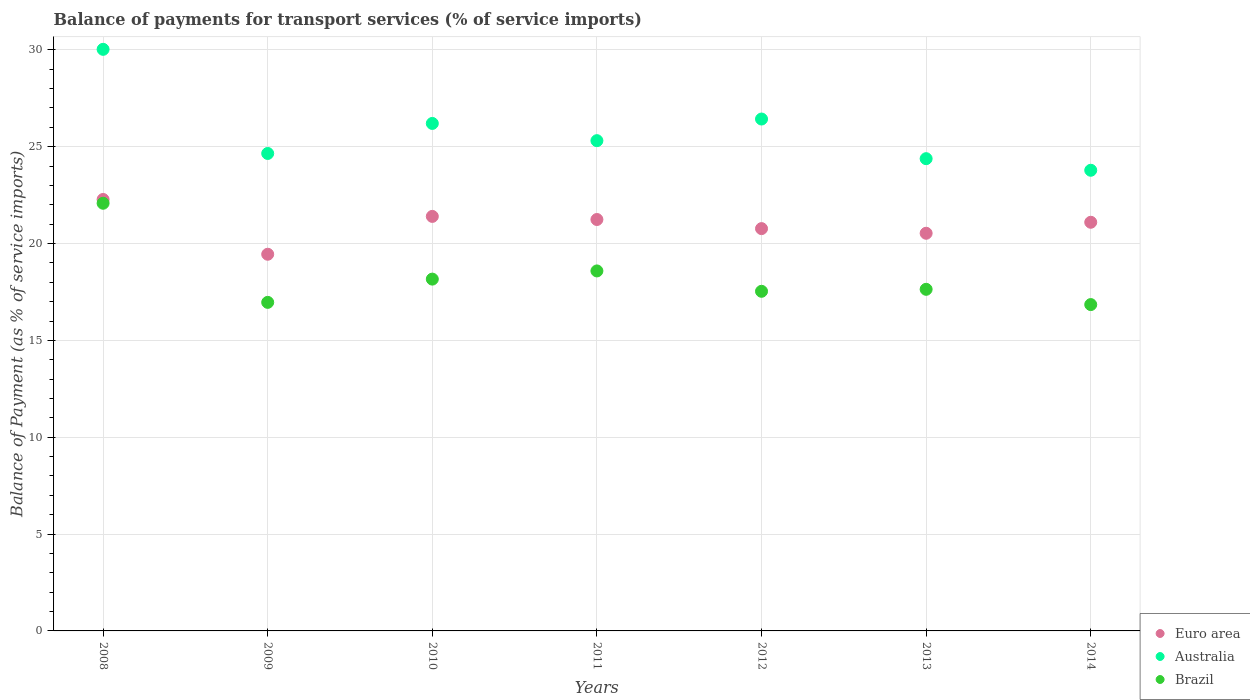What is the balance of payments for transport services in Australia in 2008?
Provide a succinct answer. 30.03. Across all years, what is the maximum balance of payments for transport services in Euro area?
Provide a short and direct response. 22.28. Across all years, what is the minimum balance of payments for transport services in Australia?
Make the answer very short. 23.78. In which year was the balance of payments for transport services in Euro area maximum?
Provide a succinct answer. 2008. In which year was the balance of payments for transport services in Australia minimum?
Provide a short and direct response. 2014. What is the total balance of payments for transport services in Euro area in the graph?
Offer a terse response. 146.76. What is the difference between the balance of payments for transport services in Australia in 2011 and that in 2014?
Your response must be concise. 1.53. What is the difference between the balance of payments for transport services in Euro area in 2014 and the balance of payments for transport services in Australia in 2009?
Provide a short and direct response. -3.55. What is the average balance of payments for transport services in Euro area per year?
Keep it short and to the point. 20.97. In the year 2011, what is the difference between the balance of payments for transport services in Australia and balance of payments for transport services in Brazil?
Provide a short and direct response. 6.73. What is the ratio of the balance of payments for transport services in Australia in 2009 to that in 2010?
Your answer should be compact. 0.94. What is the difference between the highest and the second highest balance of payments for transport services in Brazil?
Offer a terse response. 3.49. What is the difference between the highest and the lowest balance of payments for transport services in Brazil?
Your response must be concise. 5.23. Is it the case that in every year, the sum of the balance of payments for transport services in Euro area and balance of payments for transport services in Brazil  is greater than the balance of payments for transport services in Australia?
Your answer should be very brief. Yes. Does the balance of payments for transport services in Brazil monotonically increase over the years?
Your answer should be compact. No. Is the balance of payments for transport services in Brazil strictly greater than the balance of payments for transport services in Euro area over the years?
Offer a very short reply. No. Is the balance of payments for transport services in Australia strictly less than the balance of payments for transport services in Brazil over the years?
Give a very brief answer. No. How many dotlines are there?
Give a very brief answer. 3. How many years are there in the graph?
Your answer should be very brief. 7. Does the graph contain any zero values?
Offer a very short reply. No. Does the graph contain grids?
Your answer should be very brief. Yes. Where does the legend appear in the graph?
Give a very brief answer. Bottom right. How many legend labels are there?
Offer a very short reply. 3. What is the title of the graph?
Your response must be concise. Balance of payments for transport services (% of service imports). What is the label or title of the X-axis?
Your answer should be very brief. Years. What is the label or title of the Y-axis?
Your response must be concise. Balance of Payment (as % of service imports). What is the Balance of Payment (as % of service imports) of Euro area in 2008?
Give a very brief answer. 22.28. What is the Balance of Payment (as % of service imports) of Australia in 2008?
Provide a short and direct response. 30.03. What is the Balance of Payment (as % of service imports) of Brazil in 2008?
Provide a short and direct response. 22.08. What is the Balance of Payment (as % of service imports) in Euro area in 2009?
Ensure brevity in your answer.  19.45. What is the Balance of Payment (as % of service imports) of Australia in 2009?
Offer a very short reply. 24.65. What is the Balance of Payment (as % of service imports) in Brazil in 2009?
Your answer should be compact. 16.96. What is the Balance of Payment (as % of service imports) of Euro area in 2010?
Keep it short and to the point. 21.4. What is the Balance of Payment (as % of service imports) of Australia in 2010?
Your response must be concise. 26.2. What is the Balance of Payment (as % of service imports) in Brazil in 2010?
Your answer should be very brief. 18.16. What is the Balance of Payment (as % of service imports) in Euro area in 2011?
Give a very brief answer. 21.24. What is the Balance of Payment (as % of service imports) in Australia in 2011?
Make the answer very short. 25.31. What is the Balance of Payment (as % of service imports) in Brazil in 2011?
Provide a short and direct response. 18.59. What is the Balance of Payment (as % of service imports) in Euro area in 2012?
Provide a succinct answer. 20.77. What is the Balance of Payment (as % of service imports) of Australia in 2012?
Your answer should be very brief. 26.43. What is the Balance of Payment (as % of service imports) in Brazil in 2012?
Make the answer very short. 17.53. What is the Balance of Payment (as % of service imports) of Euro area in 2013?
Give a very brief answer. 20.53. What is the Balance of Payment (as % of service imports) of Australia in 2013?
Provide a short and direct response. 24.38. What is the Balance of Payment (as % of service imports) in Brazil in 2013?
Your response must be concise. 17.64. What is the Balance of Payment (as % of service imports) of Euro area in 2014?
Offer a very short reply. 21.1. What is the Balance of Payment (as % of service imports) of Australia in 2014?
Your answer should be very brief. 23.78. What is the Balance of Payment (as % of service imports) of Brazil in 2014?
Offer a terse response. 16.85. Across all years, what is the maximum Balance of Payment (as % of service imports) in Euro area?
Offer a very short reply. 22.28. Across all years, what is the maximum Balance of Payment (as % of service imports) of Australia?
Give a very brief answer. 30.03. Across all years, what is the maximum Balance of Payment (as % of service imports) in Brazil?
Your response must be concise. 22.08. Across all years, what is the minimum Balance of Payment (as % of service imports) of Euro area?
Keep it short and to the point. 19.45. Across all years, what is the minimum Balance of Payment (as % of service imports) of Australia?
Offer a terse response. 23.78. Across all years, what is the minimum Balance of Payment (as % of service imports) in Brazil?
Your response must be concise. 16.85. What is the total Balance of Payment (as % of service imports) in Euro area in the graph?
Offer a very short reply. 146.76. What is the total Balance of Payment (as % of service imports) in Australia in the graph?
Ensure brevity in your answer.  180.78. What is the total Balance of Payment (as % of service imports) in Brazil in the graph?
Your answer should be compact. 127.81. What is the difference between the Balance of Payment (as % of service imports) in Euro area in 2008 and that in 2009?
Ensure brevity in your answer.  2.83. What is the difference between the Balance of Payment (as % of service imports) in Australia in 2008 and that in 2009?
Make the answer very short. 5.38. What is the difference between the Balance of Payment (as % of service imports) of Brazil in 2008 and that in 2009?
Your answer should be compact. 5.12. What is the difference between the Balance of Payment (as % of service imports) in Euro area in 2008 and that in 2010?
Your answer should be compact. 0.87. What is the difference between the Balance of Payment (as % of service imports) of Australia in 2008 and that in 2010?
Provide a succinct answer. 3.83. What is the difference between the Balance of Payment (as % of service imports) in Brazil in 2008 and that in 2010?
Your answer should be very brief. 3.92. What is the difference between the Balance of Payment (as % of service imports) in Euro area in 2008 and that in 2011?
Provide a succinct answer. 1.03. What is the difference between the Balance of Payment (as % of service imports) of Australia in 2008 and that in 2011?
Offer a terse response. 4.72. What is the difference between the Balance of Payment (as % of service imports) in Brazil in 2008 and that in 2011?
Provide a short and direct response. 3.49. What is the difference between the Balance of Payment (as % of service imports) in Euro area in 2008 and that in 2012?
Your response must be concise. 1.5. What is the difference between the Balance of Payment (as % of service imports) of Australia in 2008 and that in 2012?
Offer a terse response. 3.6. What is the difference between the Balance of Payment (as % of service imports) in Brazil in 2008 and that in 2012?
Your response must be concise. 4.55. What is the difference between the Balance of Payment (as % of service imports) of Euro area in 2008 and that in 2013?
Your answer should be compact. 1.74. What is the difference between the Balance of Payment (as % of service imports) of Australia in 2008 and that in 2013?
Offer a very short reply. 5.64. What is the difference between the Balance of Payment (as % of service imports) in Brazil in 2008 and that in 2013?
Offer a very short reply. 4.44. What is the difference between the Balance of Payment (as % of service imports) of Euro area in 2008 and that in 2014?
Your answer should be compact. 1.18. What is the difference between the Balance of Payment (as % of service imports) in Australia in 2008 and that in 2014?
Make the answer very short. 6.24. What is the difference between the Balance of Payment (as % of service imports) in Brazil in 2008 and that in 2014?
Provide a succinct answer. 5.23. What is the difference between the Balance of Payment (as % of service imports) of Euro area in 2009 and that in 2010?
Your answer should be compact. -1.95. What is the difference between the Balance of Payment (as % of service imports) of Australia in 2009 and that in 2010?
Provide a short and direct response. -1.55. What is the difference between the Balance of Payment (as % of service imports) of Brazil in 2009 and that in 2010?
Provide a succinct answer. -1.2. What is the difference between the Balance of Payment (as % of service imports) of Euro area in 2009 and that in 2011?
Offer a terse response. -1.79. What is the difference between the Balance of Payment (as % of service imports) of Australia in 2009 and that in 2011?
Your response must be concise. -0.66. What is the difference between the Balance of Payment (as % of service imports) of Brazil in 2009 and that in 2011?
Make the answer very short. -1.62. What is the difference between the Balance of Payment (as % of service imports) in Euro area in 2009 and that in 2012?
Offer a very short reply. -1.32. What is the difference between the Balance of Payment (as % of service imports) in Australia in 2009 and that in 2012?
Your answer should be very brief. -1.78. What is the difference between the Balance of Payment (as % of service imports) in Brazil in 2009 and that in 2012?
Offer a terse response. -0.57. What is the difference between the Balance of Payment (as % of service imports) in Euro area in 2009 and that in 2013?
Offer a terse response. -1.08. What is the difference between the Balance of Payment (as % of service imports) in Australia in 2009 and that in 2013?
Offer a terse response. 0.27. What is the difference between the Balance of Payment (as % of service imports) in Brazil in 2009 and that in 2013?
Your answer should be compact. -0.67. What is the difference between the Balance of Payment (as % of service imports) in Euro area in 2009 and that in 2014?
Your response must be concise. -1.65. What is the difference between the Balance of Payment (as % of service imports) of Australia in 2009 and that in 2014?
Offer a very short reply. 0.87. What is the difference between the Balance of Payment (as % of service imports) of Brazil in 2009 and that in 2014?
Provide a short and direct response. 0.11. What is the difference between the Balance of Payment (as % of service imports) in Euro area in 2010 and that in 2011?
Your response must be concise. 0.16. What is the difference between the Balance of Payment (as % of service imports) in Australia in 2010 and that in 2011?
Ensure brevity in your answer.  0.89. What is the difference between the Balance of Payment (as % of service imports) in Brazil in 2010 and that in 2011?
Keep it short and to the point. -0.42. What is the difference between the Balance of Payment (as % of service imports) of Euro area in 2010 and that in 2012?
Provide a succinct answer. 0.63. What is the difference between the Balance of Payment (as % of service imports) in Australia in 2010 and that in 2012?
Your answer should be very brief. -0.23. What is the difference between the Balance of Payment (as % of service imports) in Brazil in 2010 and that in 2012?
Provide a succinct answer. 0.63. What is the difference between the Balance of Payment (as % of service imports) of Euro area in 2010 and that in 2013?
Give a very brief answer. 0.87. What is the difference between the Balance of Payment (as % of service imports) in Australia in 2010 and that in 2013?
Keep it short and to the point. 1.82. What is the difference between the Balance of Payment (as % of service imports) of Brazil in 2010 and that in 2013?
Your answer should be compact. 0.53. What is the difference between the Balance of Payment (as % of service imports) of Euro area in 2010 and that in 2014?
Ensure brevity in your answer.  0.3. What is the difference between the Balance of Payment (as % of service imports) in Australia in 2010 and that in 2014?
Provide a short and direct response. 2.42. What is the difference between the Balance of Payment (as % of service imports) of Brazil in 2010 and that in 2014?
Make the answer very short. 1.32. What is the difference between the Balance of Payment (as % of service imports) of Euro area in 2011 and that in 2012?
Your answer should be very brief. 0.47. What is the difference between the Balance of Payment (as % of service imports) of Australia in 2011 and that in 2012?
Your answer should be compact. -1.12. What is the difference between the Balance of Payment (as % of service imports) of Brazil in 2011 and that in 2012?
Give a very brief answer. 1.05. What is the difference between the Balance of Payment (as % of service imports) in Euro area in 2011 and that in 2013?
Make the answer very short. 0.71. What is the difference between the Balance of Payment (as % of service imports) of Australia in 2011 and that in 2013?
Offer a very short reply. 0.93. What is the difference between the Balance of Payment (as % of service imports) of Brazil in 2011 and that in 2013?
Offer a terse response. 0.95. What is the difference between the Balance of Payment (as % of service imports) of Euro area in 2011 and that in 2014?
Your answer should be very brief. 0.14. What is the difference between the Balance of Payment (as % of service imports) of Australia in 2011 and that in 2014?
Provide a succinct answer. 1.53. What is the difference between the Balance of Payment (as % of service imports) in Brazil in 2011 and that in 2014?
Offer a terse response. 1.74. What is the difference between the Balance of Payment (as % of service imports) of Euro area in 2012 and that in 2013?
Keep it short and to the point. 0.24. What is the difference between the Balance of Payment (as % of service imports) of Australia in 2012 and that in 2013?
Offer a terse response. 2.05. What is the difference between the Balance of Payment (as % of service imports) in Brazil in 2012 and that in 2013?
Offer a terse response. -0.1. What is the difference between the Balance of Payment (as % of service imports) of Euro area in 2012 and that in 2014?
Your answer should be very brief. -0.33. What is the difference between the Balance of Payment (as % of service imports) of Australia in 2012 and that in 2014?
Provide a succinct answer. 2.65. What is the difference between the Balance of Payment (as % of service imports) of Brazil in 2012 and that in 2014?
Provide a short and direct response. 0.69. What is the difference between the Balance of Payment (as % of service imports) in Euro area in 2013 and that in 2014?
Keep it short and to the point. -0.57. What is the difference between the Balance of Payment (as % of service imports) in Australia in 2013 and that in 2014?
Your answer should be very brief. 0.6. What is the difference between the Balance of Payment (as % of service imports) of Brazil in 2013 and that in 2014?
Offer a terse response. 0.79. What is the difference between the Balance of Payment (as % of service imports) of Euro area in 2008 and the Balance of Payment (as % of service imports) of Australia in 2009?
Provide a succinct answer. -2.38. What is the difference between the Balance of Payment (as % of service imports) of Euro area in 2008 and the Balance of Payment (as % of service imports) of Brazil in 2009?
Give a very brief answer. 5.31. What is the difference between the Balance of Payment (as % of service imports) of Australia in 2008 and the Balance of Payment (as % of service imports) of Brazil in 2009?
Offer a terse response. 13.06. What is the difference between the Balance of Payment (as % of service imports) in Euro area in 2008 and the Balance of Payment (as % of service imports) in Australia in 2010?
Give a very brief answer. -3.93. What is the difference between the Balance of Payment (as % of service imports) of Euro area in 2008 and the Balance of Payment (as % of service imports) of Brazil in 2010?
Offer a very short reply. 4.11. What is the difference between the Balance of Payment (as % of service imports) in Australia in 2008 and the Balance of Payment (as % of service imports) in Brazil in 2010?
Provide a succinct answer. 11.86. What is the difference between the Balance of Payment (as % of service imports) in Euro area in 2008 and the Balance of Payment (as % of service imports) in Australia in 2011?
Provide a short and direct response. -3.04. What is the difference between the Balance of Payment (as % of service imports) in Euro area in 2008 and the Balance of Payment (as % of service imports) in Brazil in 2011?
Make the answer very short. 3.69. What is the difference between the Balance of Payment (as % of service imports) in Australia in 2008 and the Balance of Payment (as % of service imports) in Brazil in 2011?
Offer a very short reply. 11.44. What is the difference between the Balance of Payment (as % of service imports) in Euro area in 2008 and the Balance of Payment (as % of service imports) in Australia in 2012?
Make the answer very short. -4.15. What is the difference between the Balance of Payment (as % of service imports) in Euro area in 2008 and the Balance of Payment (as % of service imports) in Brazil in 2012?
Your response must be concise. 4.74. What is the difference between the Balance of Payment (as % of service imports) in Australia in 2008 and the Balance of Payment (as % of service imports) in Brazil in 2012?
Ensure brevity in your answer.  12.49. What is the difference between the Balance of Payment (as % of service imports) in Euro area in 2008 and the Balance of Payment (as % of service imports) in Australia in 2013?
Offer a very short reply. -2.11. What is the difference between the Balance of Payment (as % of service imports) of Euro area in 2008 and the Balance of Payment (as % of service imports) of Brazil in 2013?
Your answer should be compact. 4.64. What is the difference between the Balance of Payment (as % of service imports) of Australia in 2008 and the Balance of Payment (as % of service imports) of Brazil in 2013?
Offer a terse response. 12.39. What is the difference between the Balance of Payment (as % of service imports) in Euro area in 2008 and the Balance of Payment (as % of service imports) in Australia in 2014?
Make the answer very short. -1.51. What is the difference between the Balance of Payment (as % of service imports) of Euro area in 2008 and the Balance of Payment (as % of service imports) of Brazil in 2014?
Provide a succinct answer. 5.43. What is the difference between the Balance of Payment (as % of service imports) in Australia in 2008 and the Balance of Payment (as % of service imports) in Brazil in 2014?
Ensure brevity in your answer.  13.18. What is the difference between the Balance of Payment (as % of service imports) of Euro area in 2009 and the Balance of Payment (as % of service imports) of Australia in 2010?
Make the answer very short. -6.75. What is the difference between the Balance of Payment (as % of service imports) in Euro area in 2009 and the Balance of Payment (as % of service imports) in Brazil in 2010?
Give a very brief answer. 1.28. What is the difference between the Balance of Payment (as % of service imports) of Australia in 2009 and the Balance of Payment (as % of service imports) of Brazil in 2010?
Your answer should be compact. 6.49. What is the difference between the Balance of Payment (as % of service imports) of Euro area in 2009 and the Balance of Payment (as % of service imports) of Australia in 2011?
Make the answer very short. -5.86. What is the difference between the Balance of Payment (as % of service imports) in Euro area in 2009 and the Balance of Payment (as % of service imports) in Brazil in 2011?
Provide a succinct answer. 0.86. What is the difference between the Balance of Payment (as % of service imports) in Australia in 2009 and the Balance of Payment (as % of service imports) in Brazil in 2011?
Your answer should be compact. 6.06. What is the difference between the Balance of Payment (as % of service imports) of Euro area in 2009 and the Balance of Payment (as % of service imports) of Australia in 2012?
Keep it short and to the point. -6.98. What is the difference between the Balance of Payment (as % of service imports) of Euro area in 2009 and the Balance of Payment (as % of service imports) of Brazil in 2012?
Give a very brief answer. 1.91. What is the difference between the Balance of Payment (as % of service imports) in Australia in 2009 and the Balance of Payment (as % of service imports) in Brazil in 2012?
Give a very brief answer. 7.12. What is the difference between the Balance of Payment (as % of service imports) of Euro area in 2009 and the Balance of Payment (as % of service imports) of Australia in 2013?
Your response must be concise. -4.93. What is the difference between the Balance of Payment (as % of service imports) in Euro area in 2009 and the Balance of Payment (as % of service imports) in Brazil in 2013?
Provide a short and direct response. 1.81. What is the difference between the Balance of Payment (as % of service imports) of Australia in 2009 and the Balance of Payment (as % of service imports) of Brazil in 2013?
Offer a very short reply. 7.01. What is the difference between the Balance of Payment (as % of service imports) of Euro area in 2009 and the Balance of Payment (as % of service imports) of Australia in 2014?
Your response must be concise. -4.34. What is the difference between the Balance of Payment (as % of service imports) in Euro area in 2009 and the Balance of Payment (as % of service imports) in Brazil in 2014?
Ensure brevity in your answer.  2.6. What is the difference between the Balance of Payment (as % of service imports) in Australia in 2009 and the Balance of Payment (as % of service imports) in Brazil in 2014?
Your answer should be very brief. 7.8. What is the difference between the Balance of Payment (as % of service imports) in Euro area in 2010 and the Balance of Payment (as % of service imports) in Australia in 2011?
Your answer should be compact. -3.91. What is the difference between the Balance of Payment (as % of service imports) in Euro area in 2010 and the Balance of Payment (as % of service imports) in Brazil in 2011?
Provide a succinct answer. 2.82. What is the difference between the Balance of Payment (as % of service imports) in Australia in 2010 and the Balance of Payment (as % of service imports) in Brazil in 2011?
Ensure brevity in your answer.  7.61. What is the difference between the Balance of Payment (as % of service imports) of Euro area in 2010 and the Balance of Payment (as % of service imports) of Australia in 2012?
Offer a terse response. -5.03. What is the difference between the Balance of Payment (as % of service imports) in Euro area in 2010 and the Balance of Payment (as % of service imports) in Brazil in 2012?
Offer a terse response. 3.87. What is the difference between the Balance of Payment (as % of service imports) of Australia in 2010 and the Balance of Payment (as % of service imports) of Brazil in 2012?
Offer a very short reply. 8.67. What is the difference between the Balance of Payment (as % of service imports) of Euro area in 2010 and the Balance of Payment (as % of service imports) of Australia in 2013?
Provide a succinct answer. -2.98. What is the difference between the Balance of Payment (as % of service imports) of Euro area in 2010 and the Balance of Payment (as % of service imports) of Brazil in 2013?
Provide a succinct answer. 3.76. What is the difference between the Balance of Payment (as % of service imports) in Australia in 2010 and the Balance of Payment (as % of service imports) in Brazil in 2013?
Ensure brevity in your answer.  8.56. What is the difference between the Balance of Payment (as % of service imports) in Euro area in 2010 and the Balance of Payment (as % of service imports) in Australia in 2014?
Keep it short and to the point. -2.38. What is the difference between the Balance of Payment (as % of service imports) of Euro area in 2010 and the Balance of Payment (as % of service imports) of Brazil in 2014?
Provide a short and direct response. 4.55. What is the difference between the Balance of Payment (as % of service imports) in Australia in 2010 and the Balance of Payment (as % of service imports) in Brazil in 2014?
Offer a very short reply. 9.35. What is the difference between the Balance of Payment (as % of service imports) of Euro area in 2011 and the Balance of Payment (as % of service imports) of Australia in 2012?
Provide a succinct answer. -5.19. What is the difference between the Balance of Payment (as % of service imports) in Euro area in 2011 and the Balance of Payment (as % of service imports) in Brazil in 2012?
Your answer should be very brief. 3.71. What is the difference between the Balance of Payment (as % of service imports) of Australia in 2011 and the Balance of Payment (as % of service imports) of Brazil in 2012?
Keep it short and to the point. 7.78. What is the difference between the Balance of Payment (as % of service imports) in Euro area in 2011 and the Balance of Payment (as % of service imports) in Australia in 2013?
Give a very brief answer. -3.14. What is the difference between the Balance of Payment (as % of service imports) in Euro area in 2011 and the Balance of Payment (as % of service imports) in Brazil in 2013?
Give a very brief answer. 3.6. What is the difference between the Balance of Payment (as % of service imports) of Australia in 2011 and the Balance of Payment (as % of service imports) of Brazil in 2013?
Make the answer very short. 7.67. What is the difference between the Balance of Payment (as % of service imports) of Euro area in 2011 and the Balance of Payment (as % of service imports) of Australia in 2014?
Your answer should be compact. -2.54. What is the difference between the Balance of Payment (as % of service imports) in Euro area in 2011 and the Balance of Payment (as % of service imports) in Brazil in 2014?
Your answer should be very brief. 4.39. What is the difference between the Balance of Payment (as % of service imports) in Australia in 2011 and the Balance of Payment (as % of service imports) in Brazil in 2014?
Your answer should be very brief. 8.46. What is the difference between the Balance of Payment (as % of service imports) in Euro area in 2012 and the Balance of Payment (as % of service imports) in Australia in 2013?
Provide a succinct answer. -3.61. What is the difference between the Balance of Payment (as % of service imports) of Euro area in 2012 and the Balance of Payment (as % of service imports) of Brazil in 2013?
Give a very brief answer. 3.13. What is the difference between the Balance of Payment (as % of service imports) of Australia in 2012 and the Balance of Payment (as % of service imports) of Brazil in 2013?
Offer a very short reply. 8.79. What is the difference between the Balance of Payment (as % of service imports) in Euro area in 2012 and the Balance of Payment (as % of service imports) in Australia in 2014?
Keep it short and to the point. -3.01. What is the difference between the Balance of Payment (as % of service imports) of Euro area in 2012 and the Balance of Payment (as % of service imports) of Brazil in 2014?
Offer a very short reply. 3.92. What is the difference between the Balance of Payment (as % of service imports) in Australia in 2012 and the Balance of Payment (as % of service imports) in Brazil in 2014?
Make the answer very short. 9.58. What is the difference between the Balance of Payment (as % of service imports) of Euro area in 2013 and the Balance of Payment (as % of service imports) of Australia in 2014?
Provide a short and direct response. -3.25. What is the difference between the Balance of Payment (as % of service imports) in Euro area in 2013 and the Balance of Payment (as % of service imports) in Brazil in 2014?
Provide a succinct answer. 3.68. What is the difference between the Balance of Payment (as % of service imports) of Australia in 2013 and the Balance of Payment (as % of service imports) of Brazil in 2014?
Ensure brevity in your answer.  7.53. What is the average Balance of Payment (as % of service imports) in Euro area per year?
Offer a very short reply. 20.97. What is the average Balance of Payment (as % of service imports) in Australia per year?
Keep it short and to the point. 25.83. What is the average Balance of Payment (as % of service imports) of Brazil per year?
Your response must be concise. 18.26. In the year 2008, what is the difference between the Balance of Payment (as % of service imports) in Euro area and Balance of Payment (as % of service imports) in Australia?
Give a very brief answer. -7.75. In the year 2008, what is the difference between the Balance of Payment (as % of service imports) of Euro area and Balance of Payment (as % of service imports) of Brazil?
Offer a terse response. 0.2. In the year 2008, what is the difference between the Balance of Payment (as % of service imports) of Australia and Balance of Payment (as % of service imports) of Brazil?
Ensure brevity in your answer.  7.95. In the year 2009, what is the difference between the Balance of Payment (as % of service imports) of Euro area and Balance of Payment (as % of service imports) of Australia?
Keep it short and to the point. -5.2. In the year 2009, what is the difference between the Balance of Payment (as % of service imports) in Euro area and Balance of Payment (as % of service imports) in Brazil?
Ensure brevity in your answer.  2.48. In the year 2009, what is the difference between the Balance of Payment (as % of service imports) in Australia and Balance of Payment (as % of service imports) in Brazil?
Offer a very short reply. 7.69. In the year 2010, what is the difference between the Balance of Payment (as % of service imports) of Euro area and Balance of Payment (as % of service imports) of Australia?
Your answer should be very brief. -4.8. In the year 2010, what is the difference between the Balance of Payment (as % of service imports) of Euro area and Balance of Payment (as % of service imports) of Brazil?
Your response must be concise. 3.24. In the year 2010, what is the difference between the Balance of Payment (as % of service imports) in Australia and Balance of Payment (as % of service imports) in Brazil?
Your response must be concise. 8.04. In the year 2011, what is the difference between the Balance of Payment (as % of service imports) in Euro area and Balance of Payment (as % of service imports) in Australia?
Keep it short and to the point. -4.07. In the year 2011, what is the difference between the Balance of Payment (as % of service imports) of Euro area and Balance of Payment (as % of service imports) of Brazil?
Give a very brief answer. 2.66. In the year 2011, what is the difference between the Balance of Payment (as % of service imports) of Australia and Balance of Payment (as % of service imports) of Brazil?
Your answer should be compact. 6.73. In the year 2012, what is the difference between the Balance of Payment (as % of service imports) in Euro area and Balance of Payment (as % of service imports) in Australia?
Offer a very short reply. -5.66. In the year 2012, what is the difference between the Balance of Payment (as % of service imports) of Euro area and Balance of Payment (as % of service imports) of Brazil?
Your answer should be compact. 3.24. In the year 2012, what is the difference between the Balance of Payment (as % of service imports) in Australia and Balance of Payment (as % of service imports) in Brazil?
Provide a succinct answer. 8.89. In the year 2013, what is the difference between the Balance of Payment (as % of service imports) of Euro area and Balance of Payment (as % of service imports) of Australia?
Your answer should be very brief. -3.85. In the year 2013, what is the difference between the Balance of Payment (as % of service imports) of Euro area and Balance of Payment (as % of service imports) of Brazil?
Your answer should be very brief. 2.89. In the year 2013, what is the difference between the Balance of Payment (as % of service imports) of Australia and Balance of Payment (as % of service imports) of Brazil?
Provide a short and direct response. 6.74. In the year 2014, what is the difference between the Balance of Payment (as % of service imports) in Euro area and Balance of Payment (as % of service imports) in Australia?
Give a very brief answer. -2.68. In the year 2014, what is the difference between the Balance of Payment (as % of service imports) of Euro area and Balance of Payment (as % of service imports) of Brazil?
Your answer should be compact. 4.25. In the year 2014, what is the difference between the Balance of Payment (as % of service imports) of Australia and Balance of Payment (as % of service imports) of Brazil?
Ensure brevity in your answer.  6.93. What is the ratio of the Balance of Payment (as % of service imports) in Euro area in 2008 to that in 2009?
Your answer should be very brief. 1.15. What is the ratio of the Balance of Payment (as % of service imports) in Australia in 2008 to that in 2009?
Provide a succinct answer. 1.22. What is the ratio of the Balance of Payment (as % of service imports) in Brazil in 2008 to that in 2009?
Your answer should be compact. 1.3. What is the ratio of the Balance of Payment (as % of service imports) in Euro area in 2008 to that in 2010?
Provide a short and direct response. 1.04. What is the ratio of the Balance of Payment (as % of service imports) of Australia in 2008 to that in 2010?
Make the answer very short. 1.15. What is the ratio of the Balance of Payment (as % of service imports) of Brazil in 2008 to that in 2010?
Ensure brevity in your answer.  1.22. What is the ratio of the Balance of Payment (as % of service imports) in Euro area in 2008 to that in 2011?
Ensure brevity in your answer.  1.05. What is the ratio of the Balance of Payment (as % of service imports) of Australia in 2008 to that in 2011?
Your response must be concise. 1.19. What is the ratio of the Balance of Payment (as % of service imports) in Brazil in 2008 to that in 2011?
Keep it short and to the point. 1.19. What is the ratio of the Balance of Payment (as % of service imports) in Euro area in 2008 to that in 2012?
Make the answer very short. 1.07. What is the ratio of the Balance of Payment (as % of service imports) of Australia in 2008 to that in 2012?
Provide a short and direct response. 1.14. What is the ratio of the Balance of Payment (as % of service imports) of Brazil in 2008 to that in 2012?
Offer a very short reply. 1.26. What is the ratio of the Balance of Payment (as % of service imports) in Euro area in 2008 to that in 2013?
Your response must be concise. 1.08. What is the ratio of the Balance of Payment (as % of service imports) of Australia in 2008 to that in 2013?
Keep it short and to the point. 1.23. What is the ratio of the Balance of Payment (as % of service imports) in Brazil in 2008 to that in 2013?
Give a very brief answer. 1.25. What is the ratio of the Balance of Payment (as % of service imports) in Euro area in 2008 to that in 2014?
Keep it short and to the point. 1.06. What is the ratio of the Balance of Payment (as % of service imports) in Australia in 2008 to that in 2014?
Keep it short and to the point. 1.26. What is the ratio of the Balance of Payment (as % of service imports) of Brazil in 2008 to that in 2014?
Provide a short and direct response. 1.31. What is the ratio of the Balance of Payment (as % of service imports) in Euro area in 2009 to that in 2010?
Offer a terse response. 0.91. What is the ratio of the Balance of Payment (as % of service imports) of Australia in 2009 to that in 2010?
Ensure brevity in your answer.  0.94. What is the ratio of the Balance of Payment (as % of service imports) of Brazil in 2009 to that in 2010?
Your answer should be very brief. 0.93. What is the ratio of the Balance of Payment (as % of service imports) in Euro area in 2009 to that in 2011?
Provide a short and direct response. 0.92. What is the ratio of the Balance of Payment (as % of service imports) of Australia in 2009 to that in 2011?
Make the answer very short. 0.97. What is the ratio of the Balance of Payment (as % of service imports) in Brazil in 2009 to that in 2011?
Keep it short and to the point. 0.91. What is the ratio of the Balance of Payment (as % of service imports) in Euro area in 2009 to that in 2012?
Make the answer very short. 0.94. What is the ratio of the Balance of Payment (as % of service imports) in Australia in 2009 to that in 2012?
Keep it short and to the point. 0.93. What is the ratio of the Balance of Payment (as % of service imports) in Brazil in 2009 to that in 2012?
Your answer should be compact. 0.97. What is the ratio of the Balance of Payment (as % of service imports) in Euro area in 2009 to that in 2013?
Make the answer very short. 0.95. What is the ratio of the Balance of Payment (as % of service imports) of Brazil in 2009 to that in 2013?
Your answer should be compact. 0.96. What is the ratio of the Balance of Payment (as % of service imports) of Euro area in 2009 to that in 2014?
Give a very brief answer. 0.92. What is the ratio of the Balance of Payment (as % of service imports) in Australia in 2009 to that in 2014?
Make the answer very short. 1.04. What is the ratio of the Balance of Payment (as % of service imports) of Brazil in 2009 to that in 2014?
Your answer should be compact. 1.01. What is the ratio of the Balance of Payment (as % of service imports) in Euro area in 2010 to that in 2011?
Provide a short and direct response. 1.01. What is the ratio of the Balance of Payment (as % of service imports) in Australia in 2010 to that in 2011?
Provide a succinct answer. 1.04. What is the ratio of the Balance of Payment (as % of service imports) in Brazil in 2010 to that in 2011?
Give a very brief answer. 0.98. What is the ratio of the Balance of Payment (as % of service imports) in Euro area in 2010 to that in 2012?
Your answer should be very brief. 1.03. What is the ratio of the Balance of Payment (as % of service imports) of Brazil in 2010 to that in 2012?
Your response must be concise. 1.04. What is the ratio of the Balance of Payment (as % of service imports) in Euro area in 2010 to that in 2013?
Offer a terse response. 1.04. What is the ratio of the Balance of Payment (as % of service imports) in Australia in 2010 to that in 2013?
Ensure brevity in your answer.  1.07. What is the ratio of the Balance of Payment (as % of service imports) of Brazil in 2010 to that in 2013?
Your answer should be compact. 1.03. What is the ratio of the Balance of Payment (as % of service imports) of Euro area in 2010 to that in 2014?
Offer a very short reply. 1.01. What is the ratio of the Balance of Payment (as % of service imports) of Australia in 2010 to that in 2014?
Provide a succinct answer. 1.1. What is the ratio of the Balance of Payment (as % of service imports) of Brazil in 2010 to that in 2014?
Provide a short and direct response. 1.08. What is the ratio of the Balance of Payment (as % of service imports) of Euro area in 2011 to that in 2012?
Your answer should be compact. 1.02. What is the ratio of the Balance of Payment (as % of service imports) in Australia in 2011 to that in 2012?
Make the answer very short. 0.96. What is the ratio of the Balance of Payment (as % of service imports) in Brazil in 2011 to that in 2012?
Give a very brief answer. 1.06. What is the ratio of the Balance of Payment (as % of service imports) of Euro area in 2011 to that in 2013?
Provide a short and direct response. 1.03. What is the ratio of the Balance of Payment (as % of service imports) of Australia in 2011 to that in 2013?
Offer a very short reply. 1.04. What is the ratio of the Balance of Payment (as % of service imports) in Brazil in 2011 to that in 2013?
Provide a short and direct response. 1.05. What is the ratio of the Balance of Payment (as % of service imports) of Euro area in 2011 to that in 2014?
Offer a very short reply. 1.01. What is the ratio of the Balance of Payment (as % of service imports) in Australia in 2011 to that in 2014?
Offer a terse response. 1.06. What is the ratio of the Balance of Payment (as % of service imports) of Brazil in 2011 to that in 2014?
Give a very brief answer. 1.1. What is the ratio of the Balance of Payment (as % of service imports) in Euro area in 2012 to that in 2013?
Give a very brief answer. 1.01. What is the ratio of the Balance of Payment (as % of service imports) in Australia in 2012 to that in 2013?
Provide a short and direct response. 1.08. What is the ratio of the Balance of Payment (as % of service imports) of Euro area in 2012 to that in 2014?
Your answer should be very brief. 0.98. What is the ratio of the Balance of Payment (as % of service imports) of Australia in 2012 to that in 2014?
Provide a short and direct response. 1.11. What is the ratio of the Balance of Payment (as % of service imports) of Brazil in 2012 to that in 2014?
Ensure brevity in your answer.  1.04. What is the ratio of the Balance of Payment (as % of service imports) of Euro area in 2013 to that in 2014?
Your answer should be compact. 0.97. What is the ratio of the Balance of Payment (as % of service imports) of Australia in 2013 to that in 2014?
Your response must be concise. 1.03. What is the ratio of the Balance of Payment (as % of service imports) of Brazil in 2013 to that in 2014?
Offer a very short reply. 1.05. What is the difference between the highest and the second highest Balance of Payment (as % of service imports) of Euro area?
Your answer should be compact. 0.87. What is the difference between the highest and the second highest Balance of Payment (as % of service imports) in Australia?
Provide a succinct answer. 3.6. What is the difference between the highest and the second highest Balance of Payment (as % of service imports) in Brazil?
Your response must be concise. 3.49. What is the difference between the highest and the lowest Balance of Payment (as % of service imports) in Euro area?
Keep it short and to the point. 2.83. What is the difference between the highest and the lowest Balance of Payment (as % of service imports) in Australia?
Ensure brevity in your answer.  6.24. What is the difference between the highest and the lowest Balance of Payment (as % of service imports) in Brazil?
Give a very brief answer. 5.23. 